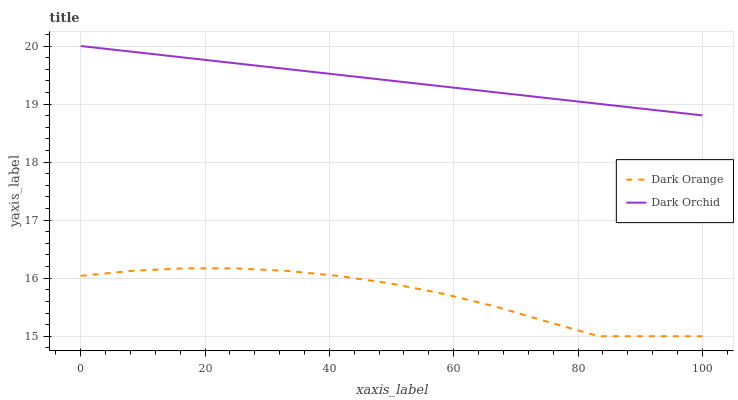Does Dark Orange have the minimum area under the curve?
Answer yes or no. Yes. Does Dark Orchid have the maximum area under the curve?
Answer yes or no. Yes. Does Dark Orchid have the minimum area under the curve?
Answer yes or no. No. Is Dark Orchid the smoothest?
Answer yes or no. Yes. Is Dark Orange the roughest?
Answer yes or no. Yes. Is Dark Orchid the roughest?
Answer yes or no. No. Does Dark Orange have the lowest value?
Answer yes or no. Yes. Does Dark Orchid have the lowest value?
Answer yes or no. No. Does Dark Orchid have the highest value?
Answer yes or no. Yes. Is Dark Orange less than Dark Orchid?
Answer yes or no. Yes. Is Dark Orchid greater than Dark Orange?
Answer yes or no. Yes. Does Dark Orange intersect Dark Orchid?
Answer yes or no. No. 